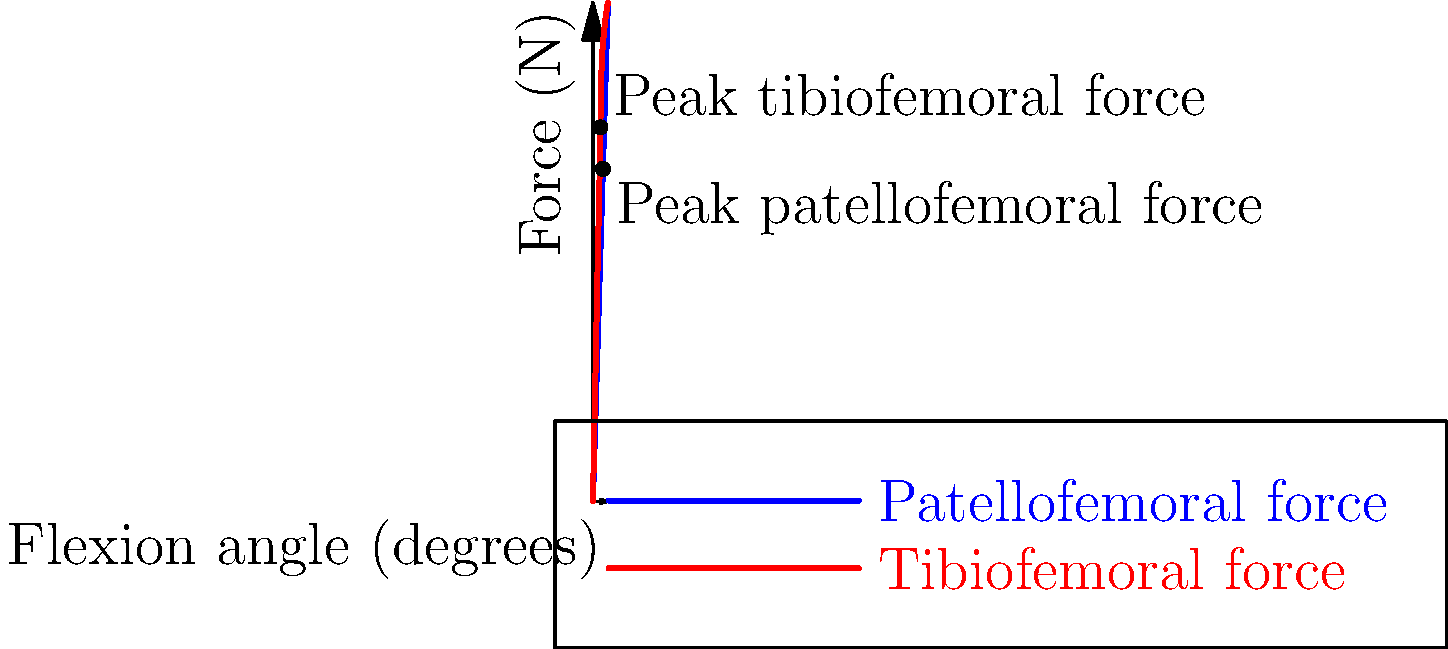Based on the graph showing the biomechanical forces acting on a knee joint during walking, at what flexion angle does the tibiofemoral force reach its peak, and how does this compare to the peak patellofemoral force? To answer this question, we need to analyze the graph and interpret the data:

1. The graph shows two curves: blue for patellofemoral force and red for tibiofemoral force.

2. The x-axis represents the flexion angle of the knee in degrees, while the y-axis shows the force in Newtons (N).

3. For the tibiofemoral force (red curve):
   - The force increases rapidly from 0° to about 45° flexion.
   - It reaches its peak at approximately 45° flexion.
   - After 45°, the rate of increase slows down.

4. For the patellofemoral force (blue curve):
   - The force increases more gradually compared to the tibiofemoral force.
   - It reaches its peak at about 60° flexion.

5. Comparing the two forces:
   - The tibiofemoral force peaks earlier (at 45°) than the patellofemoral force (at 60°).
   - The tibiofemoral force is generally higher throughout the range of motion.
   - At their respective peaks, the tibiofemoral force (about 2250 N) is higher than the patellofemoral force (about 2000 N).

6. This difference in peak angles and magnitudes is important for understanding the load distribution in the knee during walking and can inform decisions about implant design, rehabilitation protocols, and risk assessment for knee injuries.
Answer: Tibiofemoral force peaks at 45° flexion; earlier and higher than patellofemoral force (60°). 